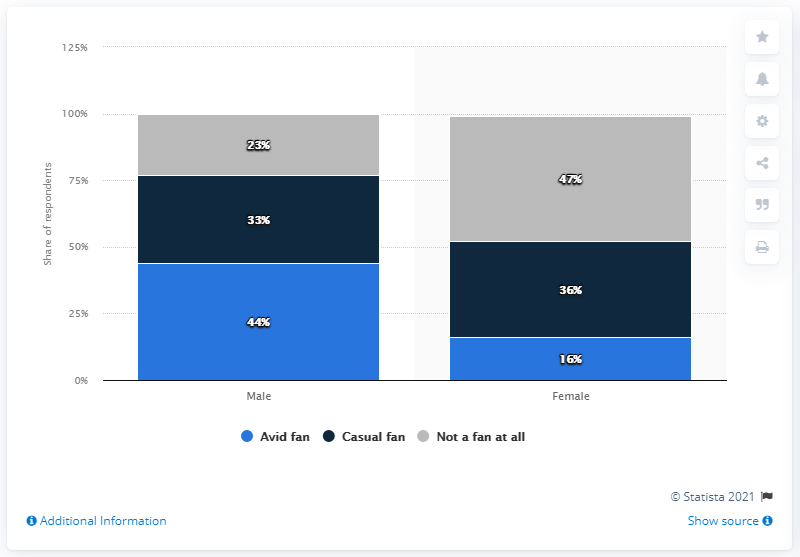Give some essential details in this illustration. If we add the two blue bar percentage values, the result would be 60. The percentage of female fans who did not respond positively to a grey bar is 47%. 